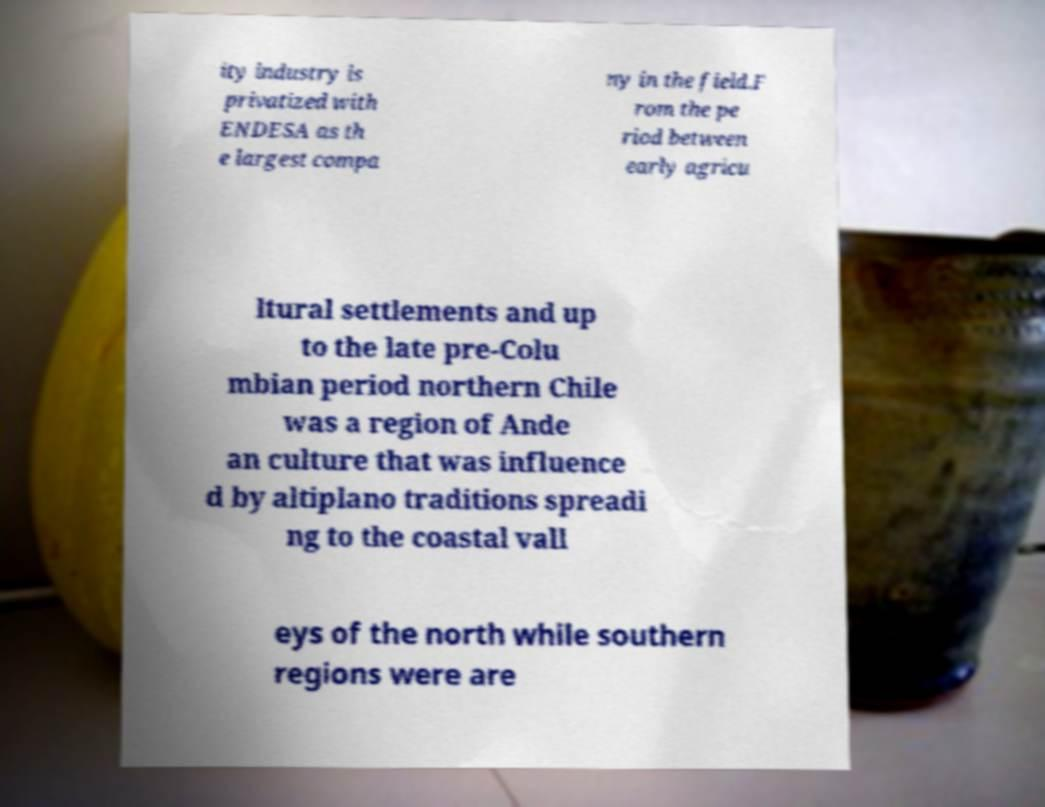There's text embedded in this image that I need extracted. Can you transcribe it verbatim? ity industry is privatized with ENDESA as th e largest compa ny in the field.F rom the pe riod between early agricu ltural settlements and up to the late pre-Colu mbian period northern Chile was a region of Ande an culture that was influence d by altiplano traditions spreadi ng to the coastal vall eys of the north while southern regions were are 